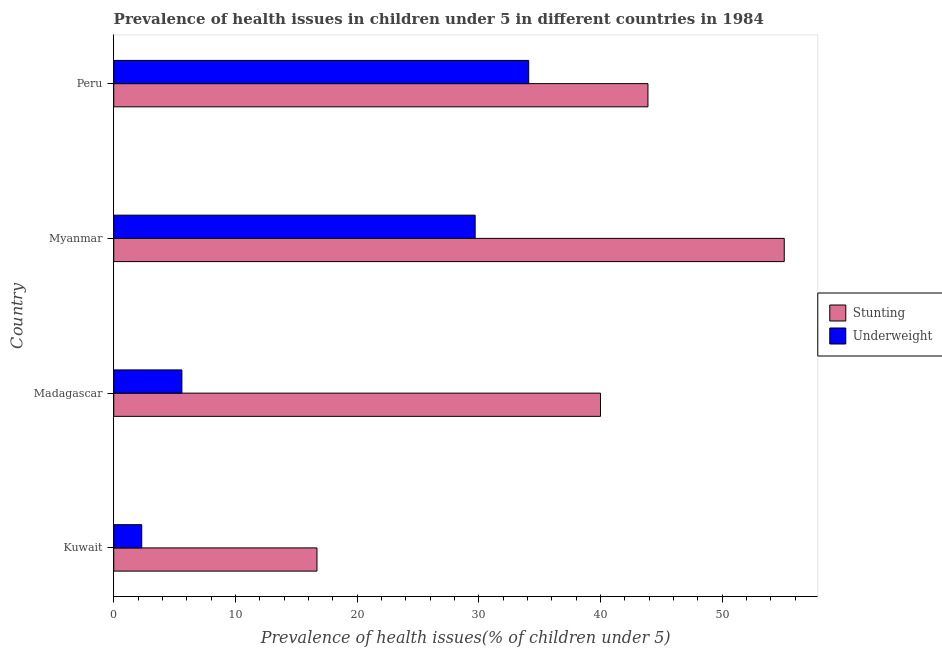How many different coloured bars are there?
Your response must be concise. 2. Are the number of bars per tick equal to the number of legend labels?
Keep it short and to the point. Yes. What is the label of the 1st group of bars from the top?
Keep it short and to the point. Peru. What is the percentage of stunted children in Kuwait?
Offer a terse response. 16.7. Across all countries, what is the maximum percentage of underweight children?
Provide a short and direct response. 34.1. Across all countries, what is the minimum percentage of stunted children?
Provide a short and direct response. 16.7. In which country was the percentage of underweight children maximum?
Offer a very short reply. Peru. In which country was the percentage of stunted children minimum?
Offer a very short reply. Kuwait. What is the total percentage of underweight children in the graph?
Offer a very short reply. 71.7. What is the difference between the percentage of stunted children in Kuwait and that in Madagascar?
Offer a terse response. -23.3. What is the difference between the percentage of underweight children in Kuwait and the percentage of stunted children in Madagascar?
Your response must be concise. -37.7. What is the average percentage of underweight children per country?
Offer a very short reply. 17.93. What is the difference between the percentage of stunted children and percentage of underweight children in Myanmar?
Provide a succinct answer. 25.4. In how many countries, is the percentage of underweight children greater than 48 %?
Provide a succinct answer. 0. What is the ratio of the percentage of underweight children in Madagascar to that in Myanmar?
Your answer should be very brief. 0.19. Is the percentage of underweight children in Kuwait less than that in Peru?
Give a very brief answer. Yes. Is the difference between the percentage of underweight children in Madagascar and Myanmar greater than the difference between the percentage of stunted children in Madagascar and Myanmar?
Offer a very short reply. No. What is the difference between the highest and the lowest percentage of stunted children?
Provide a short and direct response. 38.4. Is the sum of the percentage of stunted children in Kuwait and Peru greater than the maximum percentage of underweight children across all countries?
Your answer should be very brief. Yes. What does the 1st bar from the top in Myanmar represents?
Your answer should be compact. Underweight. What does the 2nd bar from the bottom in Peru represents?
Your answer should be very brief. Underweight. Are all the bars in the graph horizontal?
Ensure brevity in your answer.  Yes. What is the difference between two consecutive major ticks on the X-axis?
Keep it short and to the point. 10. Does the graph contain grids?
Keep it short and to the point. No. What is the title of the graph?
Your answer should be very brief. Prevalence of health issues in children under 5 in different countries in 1984. Does "Attending school" appear as one of the legend labels in the graph?
Ensure brevity in your answer.  No. What is the label or title of the X-axis?
Give a very brief answer. Prevalence of health issues(% of children under 5). What is the label or title of the Y-axis?
Keep it short and to the point. Country. What is the Prevalence of health issues(% of children under 5) of Stunting in Kuwait?
Your answer should be very brief. 16.7. What is the Prevalence of health issues(% of children under 5) of Underweight in Kuwait?
Your answer should be compact. 2.3. What is the Prevalence of health issues(% of children under 5) of Stunting in Madagascar?
Offer a terse response. 40. What is the Prevalence of health issues(% of children under 5) in Underweight in Madagascar?
Keep it short and to the point. 5.6. What is the Prevalence of health issues(% of children under 5) in Stunting in Myanmar?
Your answer should be very brief. 55.1. What is the Prevalence of health issues(% of children under 5) of Underweight in Myanmar?
Provide a succinct answer. 29.7. What is the Prevalence of health issues(% of children under 5) in Stunting in Peru?
Provide a succinct answer. 43.9. What is the Prevalence of health issues(% of children under 5) in Underweight in Peru?
Your response must be concise. 34.1. Across all countries, what is the maximum Prevalence of health issues(% of children under 5) in Stunting?
Make the answer very short. 55.1. Across all countries, what is the maximum Prevalence of health issues(% of children under 5) of Underweight?
Make the answer very short. 34.1. Across all countries, what is the minimum Prevalence of health issues(% of children under 5) of Stunting?
Provide a short and direct response. 16.7. Across all countries, what is the minimum Prevalence of health issues(% of children under 5) in Underweight?
Offer a terse response. 2.3. What is the total Prevalence of health issues(% of children under 5) of Stunting in the graph?
Your response must be concise. 155.7. What is the total Prevalence of health issues(% of children under 5) of Underweight in the graph?
Offer a very short reply. 71.7. What is the difference between the Prevalence of health issues(% of children under 5) of Stunting in Kuwait and that in Madagascar?
Give a very brief answer. -23.3. What is the difference between the Prevalence of health issues(% of children under 5) in Underweight in Kuwait and that in Madagascar?
Your answer should be compact. -3.3. What is the difference between the Prevalence of health issues(% of children under 5) of Stunting in Kuwait and that in Myanmar?
Ensure brevity in your answer.  -38.4. What is the difference between the Prevalence of health issues(% of children under 5) in Underweight in Kuwait and that in Myanmar?
Your answer should be compact. -27.4. What is the difference between the Prevalence of health issues(% of children under 5) in Stunting in Kuwait and that in Peru?
Your answer should be compact. -27.2. What is the difference between the Prevalence of health issues(% of children under 5) of Underweight in Kuwait and that in Peru?
Provide a short and direct response. -31.8. What is the difference between the Prevalence of health issues(% of children under 5) in Stunting in Madagascar and that in Myanmar?
Ensure brevity in your answer.  -15.1. What is the difference between the Prevalence of health issues(% of children under 5) in Underweight in Madagascar and that in Myanmar?
Your answer should be compact. -24.1. What is the difference between the Prevalence of health issues(% of children under 5) of Underweight in Madagascar and that in Peru?
Keep it short and to the point. -28.5. What is the difference between the Prevalence of health issues(% of children under 5) in Stunting in Kuwait and the Prevalence of health issues(% of children under 5) in Underweight in Madagascar?
Provide a short and direct response. 11.1. What is the difference between the Prevalence of health issues(% of children under 5) of Stunting in Kuwait and the Prevalence of health issues(% of children under 5) of Underweight in Peru?
Ensure brevity in your answer.  -17.4. What is the difference between the Prevalence of health issues(% of children under 5) in Stunting in Madagascar and the Prevalence of health issues(% of children under 5) in Underweight in Myanmar?
Offer a terse response. 10.3. What is the average Prevalence of health issues(% of children under 5) of Stunting per country?
Provide a succinct answer. 38.92. What is the average Prevalence of health issues(% of children under 5) of Underweight per country?
Your response must be concise. 17.93. What is the difference between the Prevalence of health issues(% of children under 5) in Stunting and Prevalence of health issues(% of children under 5) in Underweight in Madagascar?
Offer a very short reply. 34.4. What is the difference between the Prevalence of health issues(% of children under 5) of Stunting and Prevalence of health issues(% of children under 5) of Underweight in Myanmar?
Make the answer very short. 25.4. What is the difference between the Prevalence of health issues(% of children under 5) in Stunting and Prevalence of health issues(% of children under 5) in Underweight in Peru?
Offer a very short reply. 9.8. What is the ratio of the Prevalence of health issues(% of children under 5) of Stunting in Kuwait to that in Madagascar?
Your response must be concise. 0.42. What is the ratio of the Prevalence of health issues(% of children under 5) of Underweight in Kuwait to that in Madagascar?
Ensure brevity in your answer.  0.41. What is the ratio of the Prevalence of health issues(% of children under 5) in Stunting in Kuwait to that in Myanmar?
Offer a terse response. 0.3. What is the ratio of the Prevalence of health issues(% of children under 5) in Underweight in Kuwait to that in Myanmar?
Give a very brief answer. 0.08. What is the ratio of the Prevalence of health issues(% of children under 5) of Stunting in Kuwait to that in Peru?
Provide a short and direct response. 0.38. What is the ratio of the Prevalence of health issues(% of children under 5) in Underweight in Kuwait to that in Peru?
Make the answer very short. 0.07. What is the ratio of the Prevalence of health issues(% of children under 5) of Stunting in Madagascar to that in Myanmar?
Make the answer very short. 0.73. What is the ratio of the Prevalence of health issues(% of children under 5) in Underweight in Madagascar to that in Myanmar?
Make the answer very short. 0.19. What is the ratio of the Prevalence of health issues(% of children under 5) of Stunting in Madagascar to that in Peru?
Make the answer very short. 0.91. What is the ratio of the Prevalence of health issues(% of children under 5) in Underweight in Madagascar to that in Peru?
Your response must be concise. 0.16. What is the ratio of the Prevalence of health issues(% of children under 5) in Stunting in Myanmar to that in Peru?
Make the answer very short. 1.26. What is the ratio of the Prevalence of health issues(% of children under 5) in Underweight in Myanmar to that in Peru?
Your answer should be compact. 0.87. What is the difference between the highest and the second highest Prevalence of health issues(% of children under 5) in Stunting?
Offer a very short reply. 11.2. What is the difference between the highest and the lowest Prevalence of health issues(% of children under 5) in Stunting?
Your answer should be compact. 38.4. What is the difference between the highest and the lowest Prevalence of health issues(% of children under 5) of Underweight?
Your response must be concise. 31.8. 